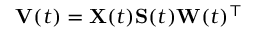<formula> <loc_0><loc_0><loc_500><loc_500>V ( t ) = X ( t ) S ( t ) W ( t ) ^ { \top }</formula> 